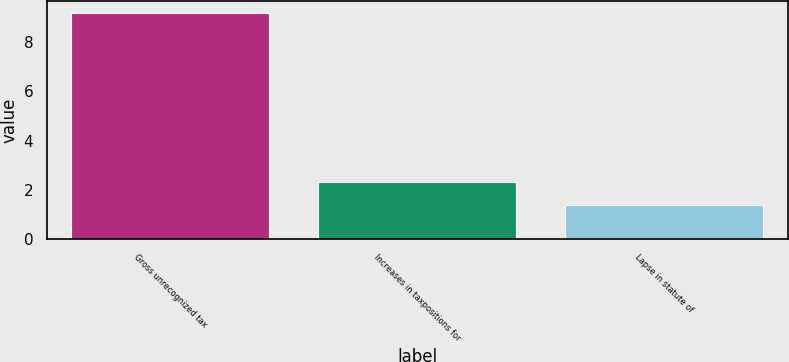<chart> <loc_0><loc_0><loc_500><loc_500><bar_chart><fcel>Gross unrecognized tax<fcel>Increases in taxpositions for<fcel>Lapse in statute of<nl><fcel>9.2<fcel>2.3<fcel>1.4<nl></chart> 